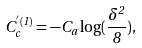<formula> <loc_0><loc_0><loc_500><loc_500>C ^ { ^ { \prime } ( 1 ) } _ { c } = - C _ { a } \log ( \frac { \delta ^ { 2 } } { 8 } ) ,</formula> 